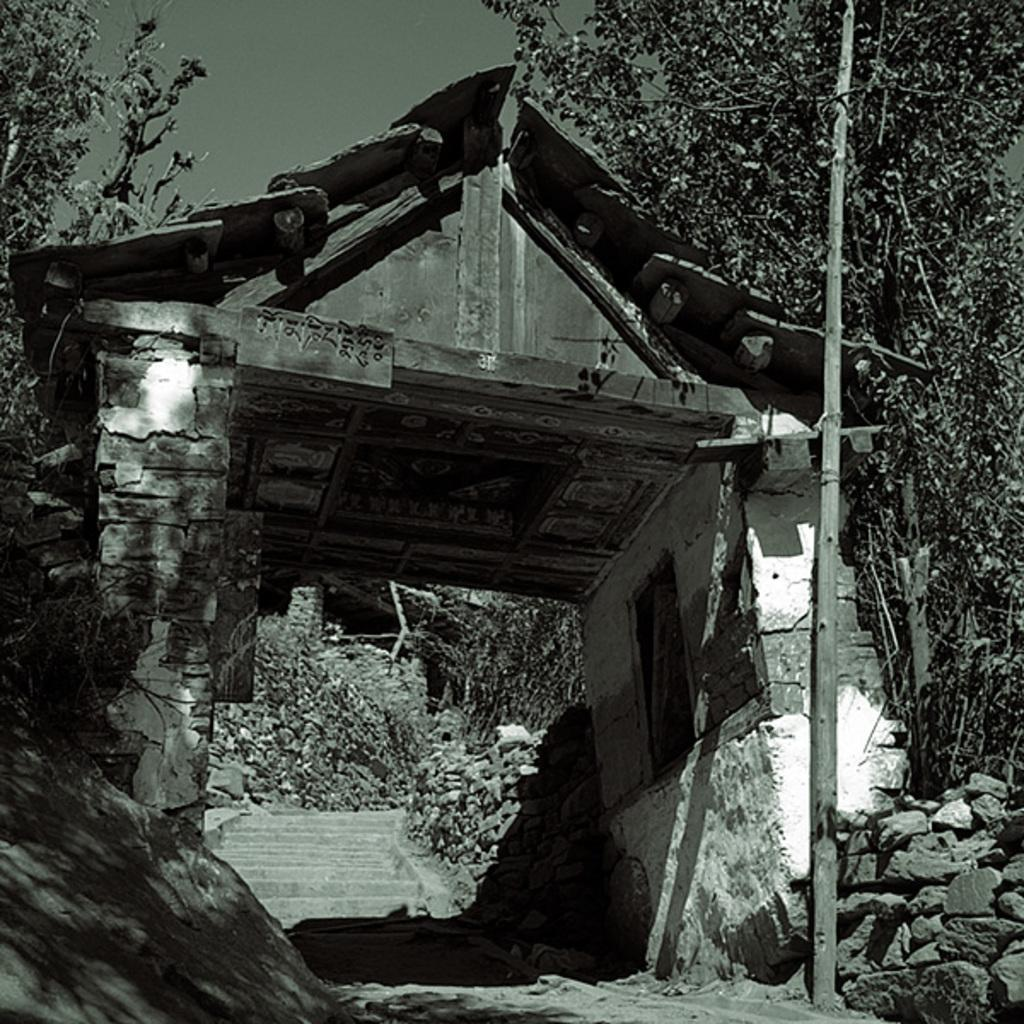What type of structure is in the foreground of the image? There is a shelter in the foreground of the image. Can you describe the shape of the shelter? The shelter is in the shape of a hut. What can be seen in the background of the image? There are trees, stones, stairs, and the sky visible in the background of the image. What type of vest is the shelter wearing in the image? The shelter is not wearing a vest, as it is a structure and not a living being. 